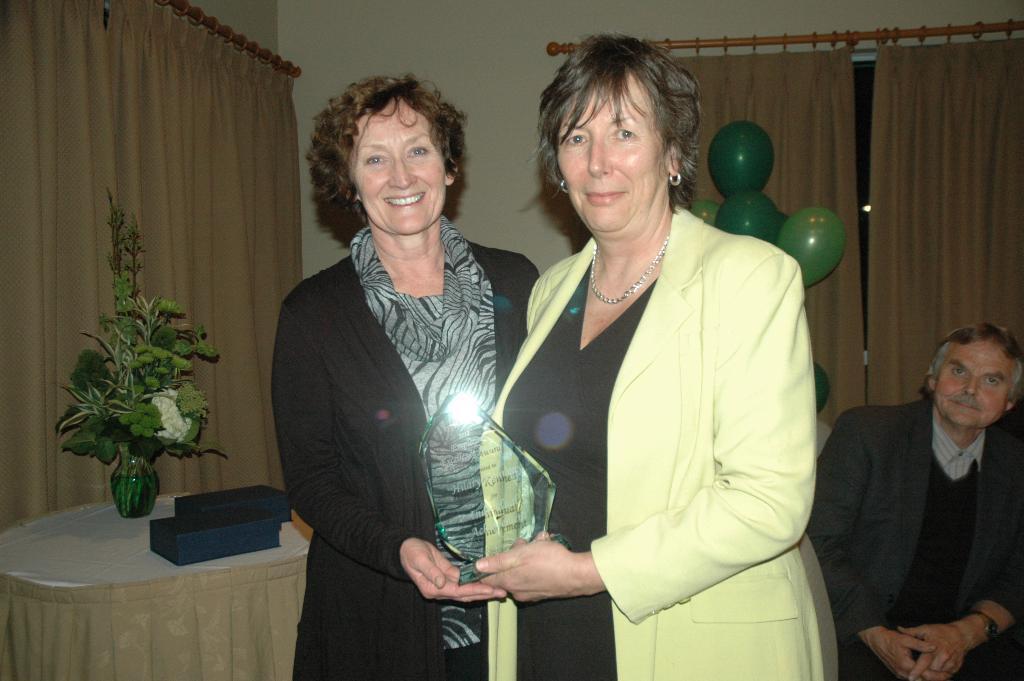Describe this image in one or two sentences. In this image we can see three persons, among them two persons are standing and holding an object and one person is sitting, also we can see a table, on the table, we can see a flower vase and other objects, there are some curtains, balloons and the wall. 